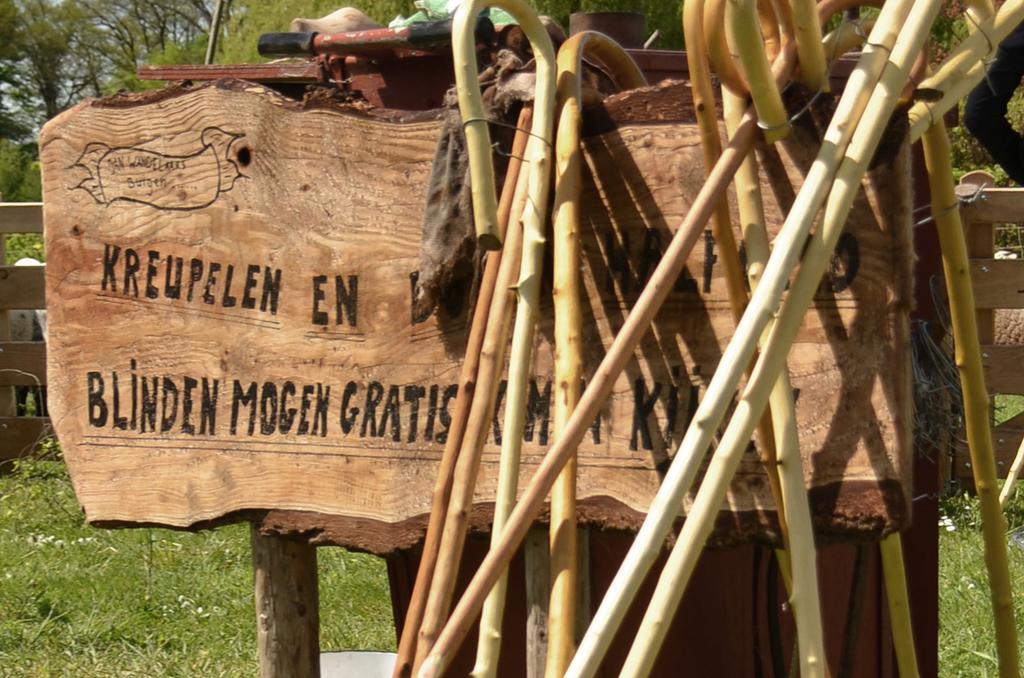In one or two sentences, can you explain what this image depicts? There is a wooden board and some wooden sticks are laid to that board,there is a lot of grass and many trees around the wooden board. 